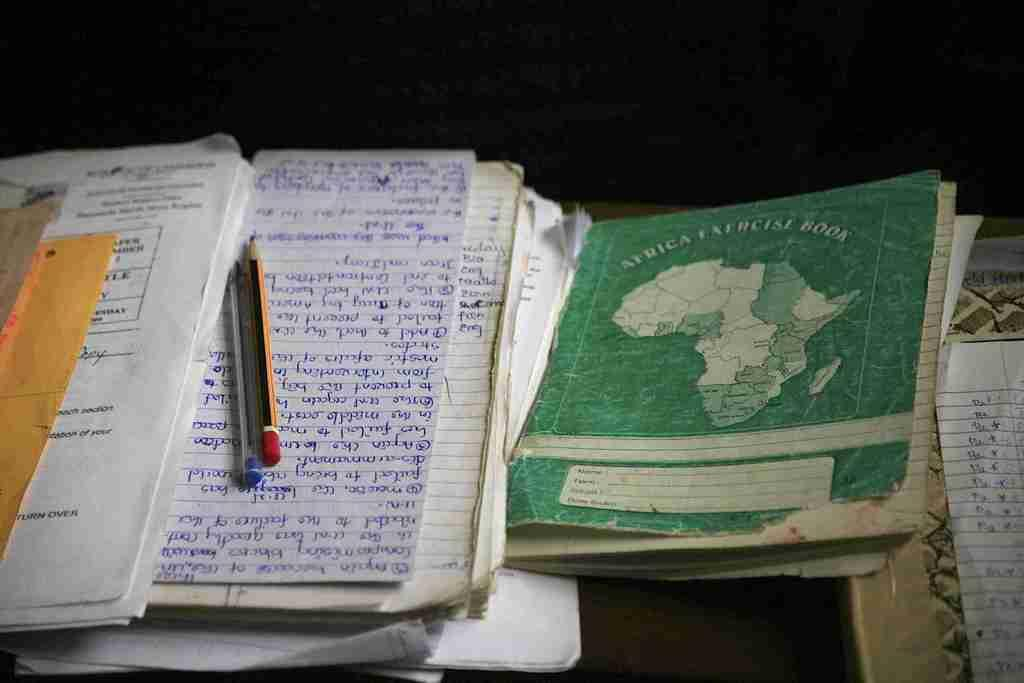<image>
Present a compact description of the photo's key features. A pen and pencil sits next to the Africa Exercise Book. 